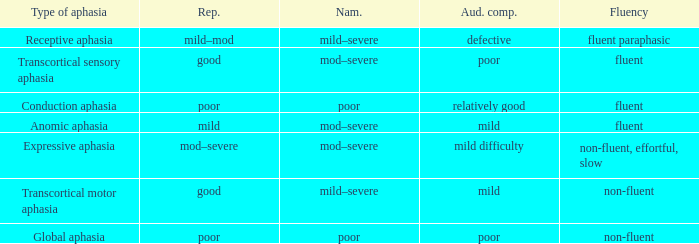Name the comprehension for non-fluent, effortful, slow Mild difficulty. 